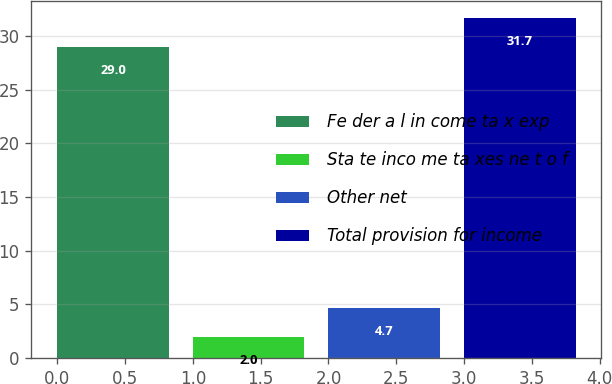<chart> <loc_0><loc_0><loc_500><loc_500><bar_chart><fcel>Fe der a l in come ta x exp<fcel>Sta te inco me ta xes ne t o f<fcel>Other net<fcel>Total provision for income<nl><fcel>29<fcel>2<fcel>4.7<fcel>31.7<nl></chart> 